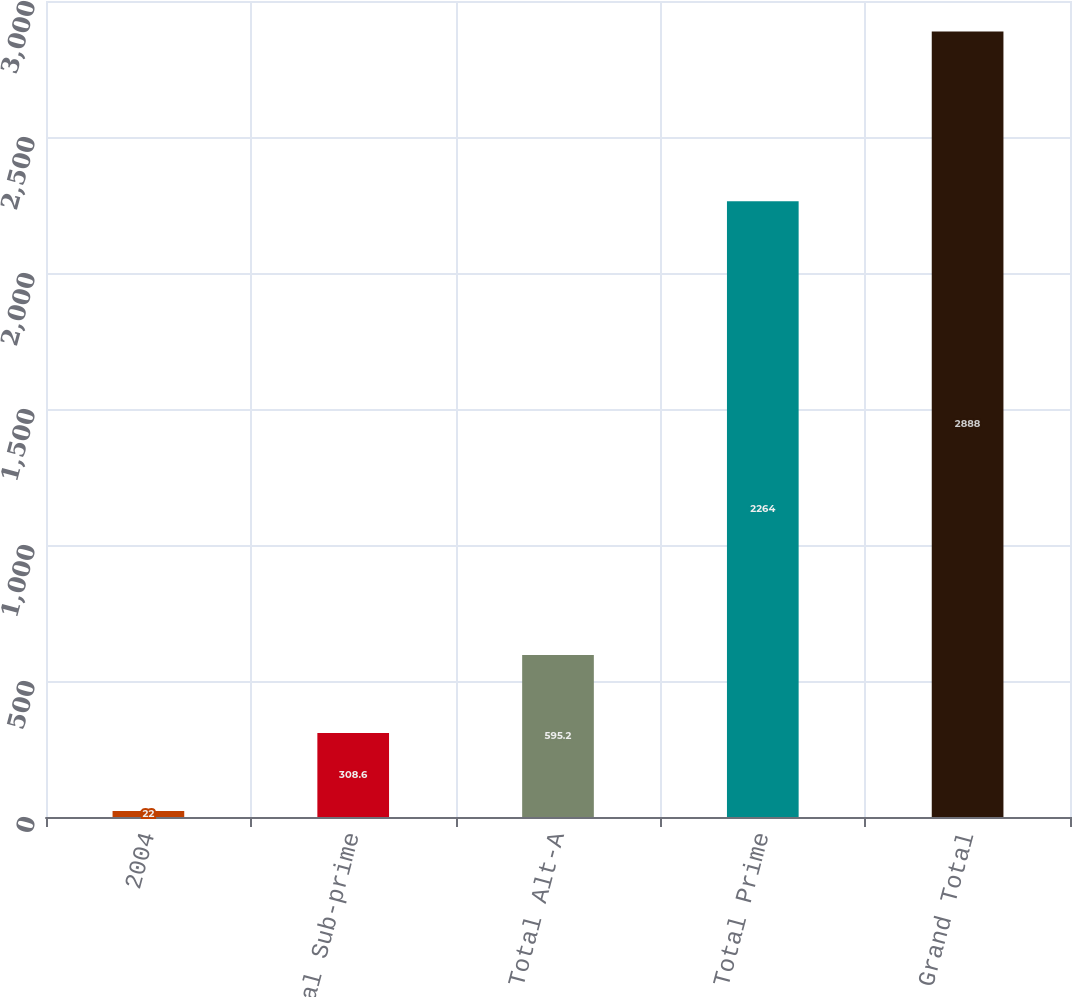Convert chart. <chart><loc_0><loc_0><loc_500><loc_500><bar_chart><fcel>2004<fcel>Total Sub-prime<fcel>Total Alt-A<fcel>Total Prime<fcel>Grand Total<nl><fcel>22<fcel>308.6<fcel>595.2<fcel>2264<fcel>2888<nl></chart> 